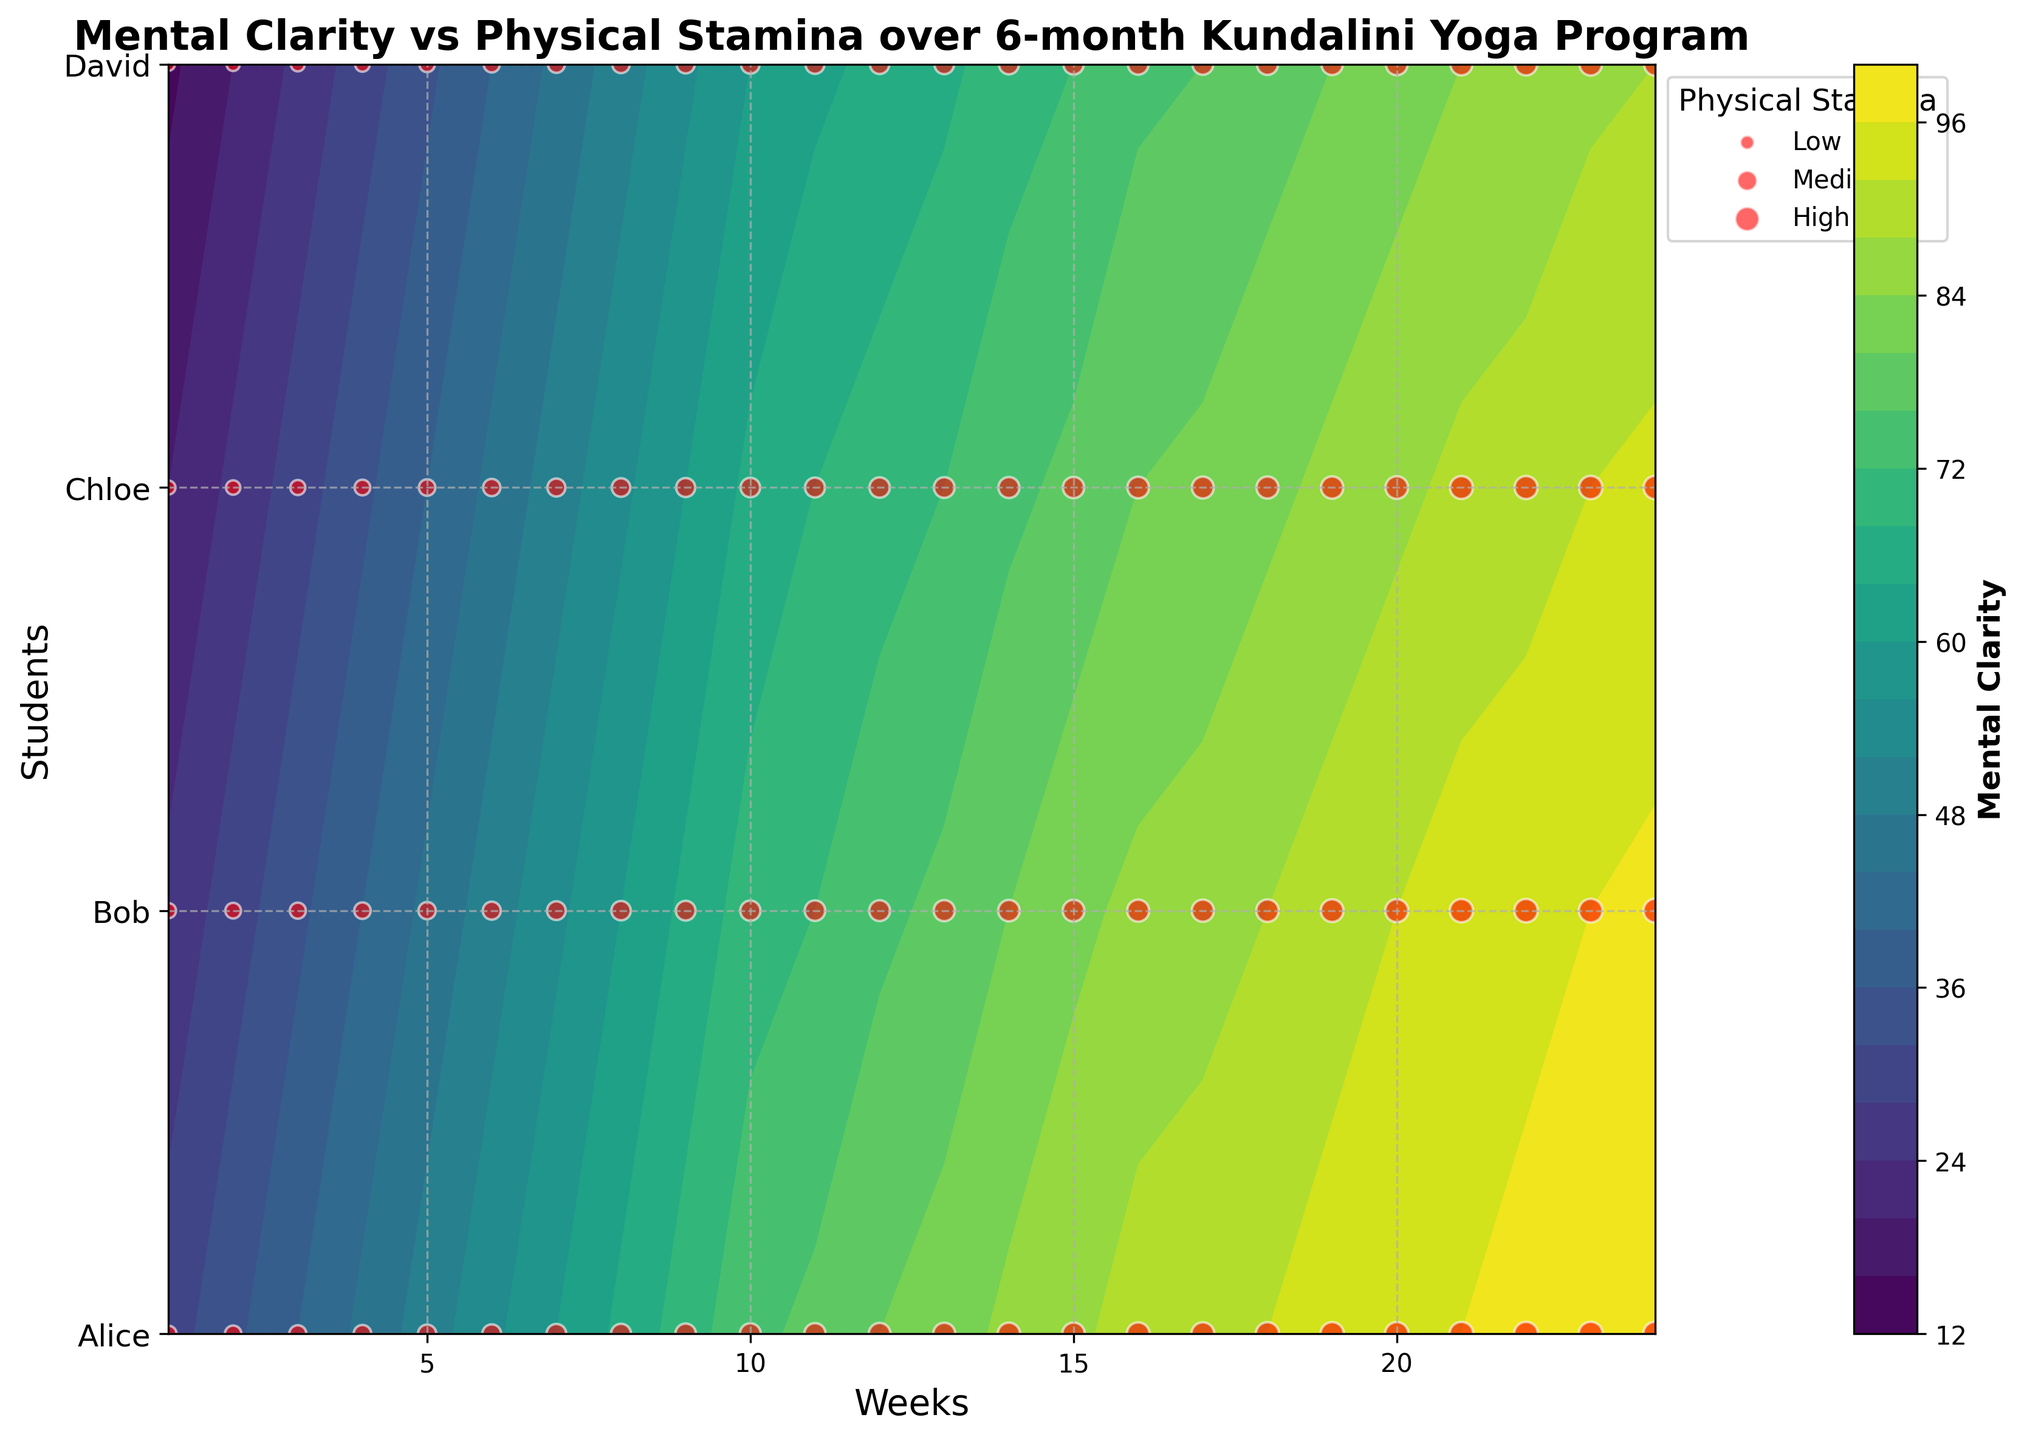What’s the title of the figure? Look at the top of the figure where the title is typically located.
Answer: Mental Clarity vs Physical Stamina over 6-month Kundalini Yoga Program How many students' data are displayed in the figure? Count the number of student names listed along the y-axis.
Answer: 4 Which student shows the highest mental clarity improvement over the 6-month period? Observe the color gradient in the contour plot and identify the student with the darkest patches.
Answer: Alice Which student starts with the lowest physical stamina? Identify the student with the smallest scatter points (represented by red dots) at the first week.
Answer: David What week shows the highest level of mental clarity for Chloe? Determine where the contour plot has the darkest patch for Chloe across the weeks.
Answer: Week 24 Between Bob and David, who has a higher physical stamina in week 10? Compare the sizes of the scatter points for Bob and David in week 10.
Answer: Bob At week 12, which student has the highest mental clarity? Check the color intensity in the contour plot for each student at week 12.
Answer: Alice Comparing Alice and Chloe, who exhibited greater improvements in mental clarity by the end of the program? Visualize the color intensity shift from week 1 to week 24 for both students and ascertain the steepness of the gradient.
Answer: Alice For which student does physical stamina increase with a higher gradient from week 1 to week 24? Compare the relative sizes of scatter points from week 1 to week 24 for all students and observe the steepness of the size increment.
Answer: Bob What relationship can be inferred about physical stamina when observing the scatter point sizes versus mental clarity from the contour plot? Analyze how the scatter point sizes (representing physical stamina) change in relation to the color gradient (representing mental clarity) across the weeks. Most students with higher mental clarity also exhibit larger scatter points.
Answer: Positive correlation between mental clarity and physical stamina 